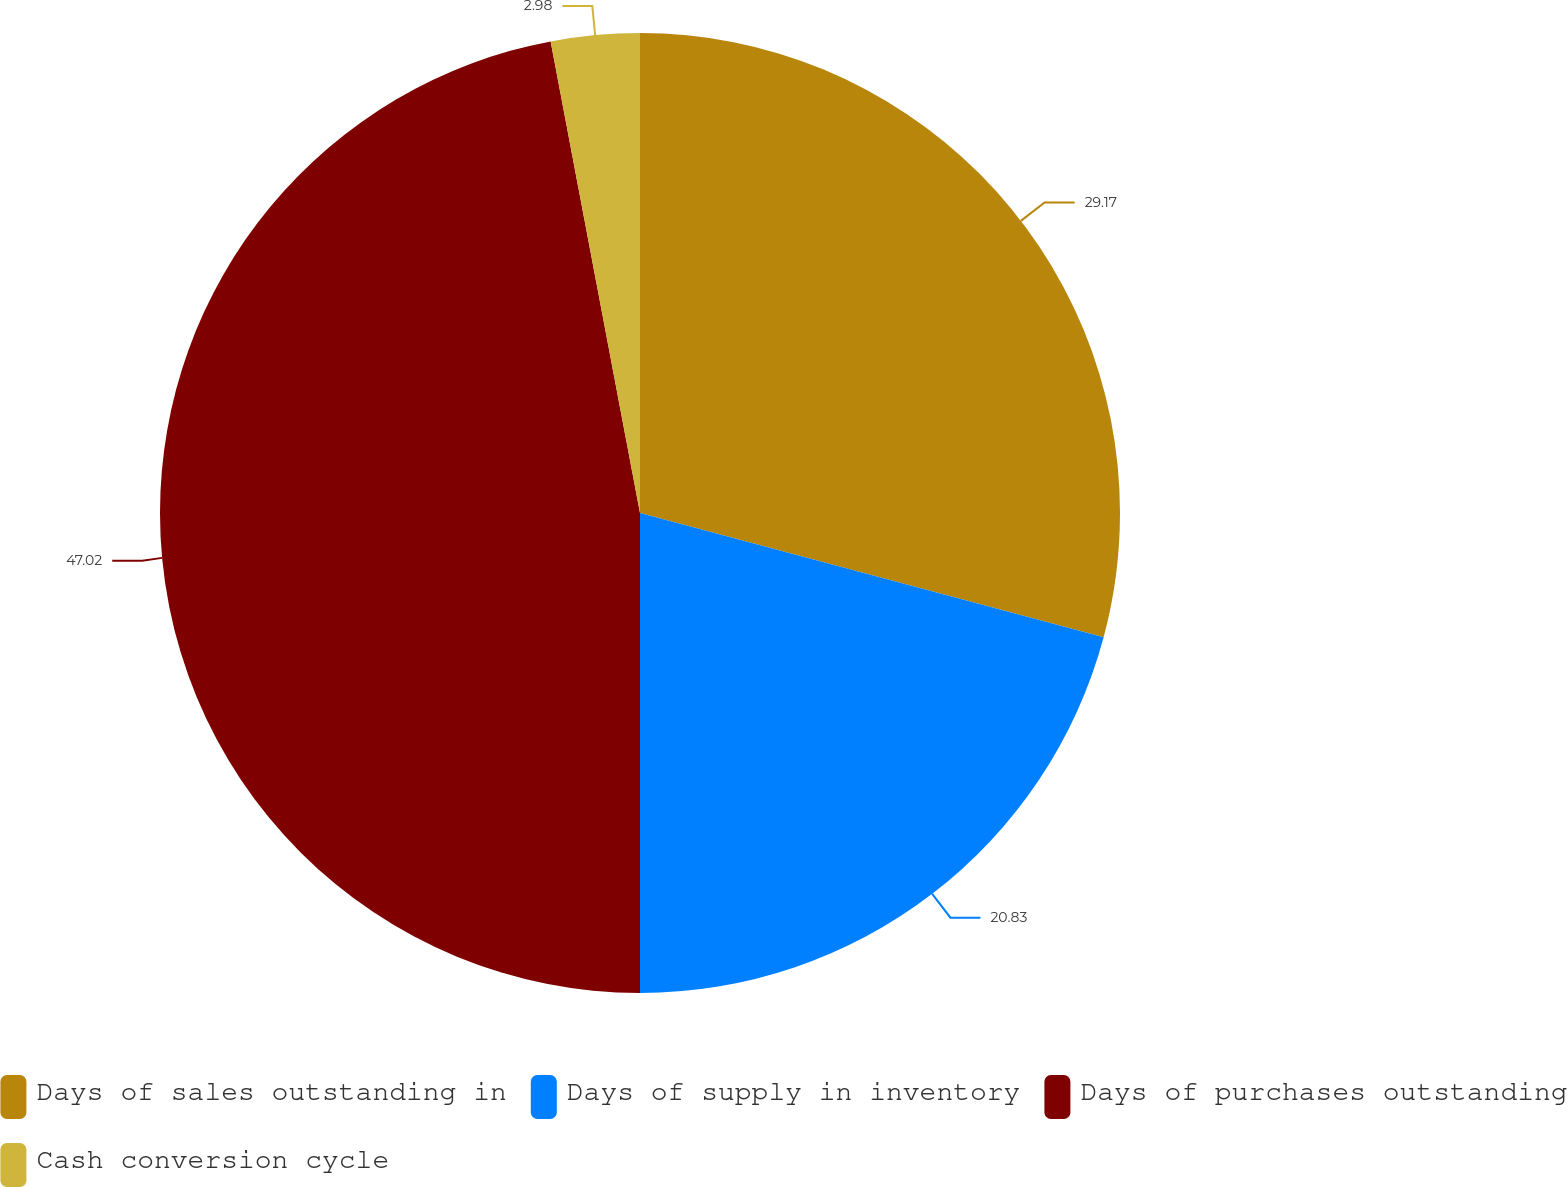<chart> <loc_0><loc_0><loc_500><loc_500><pie_chart><fcel>Days of sales outstanding in<fcel>Days of supply in inventory<fcel>Days of purchases outstanding<fcel>Cash conversion cycle<nl><fcel>29.17%<fcel>20.83%<fcel>47.02%<fcel>2.98%<nl></chart> 